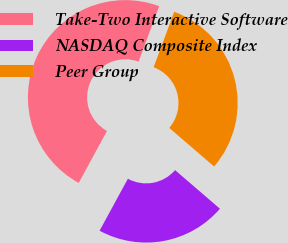Convert chart to OTSL. <chart><loc_0><loc_0><loc_500><loc_500><pie_chart><fcel>Take-Two Interactive Software<fcel>NASDAQ Composite Index<fcel>Peer Group<nl><fcel>47.73%<fcel>21.63%<fcel>30.64%<nl></chart> 